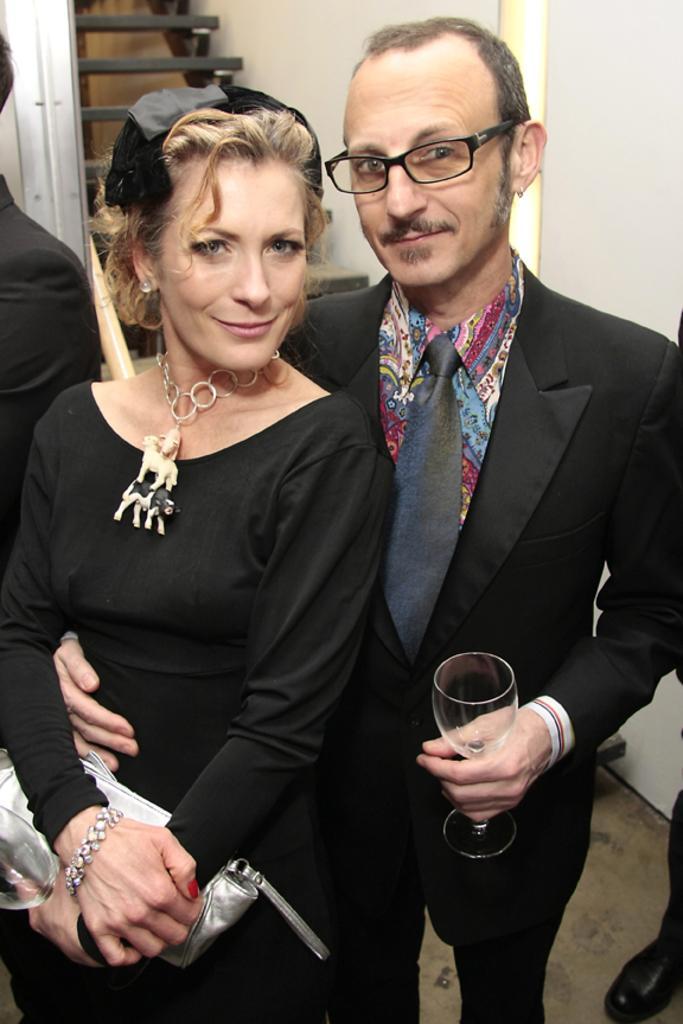In one or two sentences, can you explain what this image depicts? In this image we can see a man and woman is standing. They are wearing black color dress. Woman is holding silver color purse in her hand and the men is holding glass. Behind them white color wall and black stairs are there. 